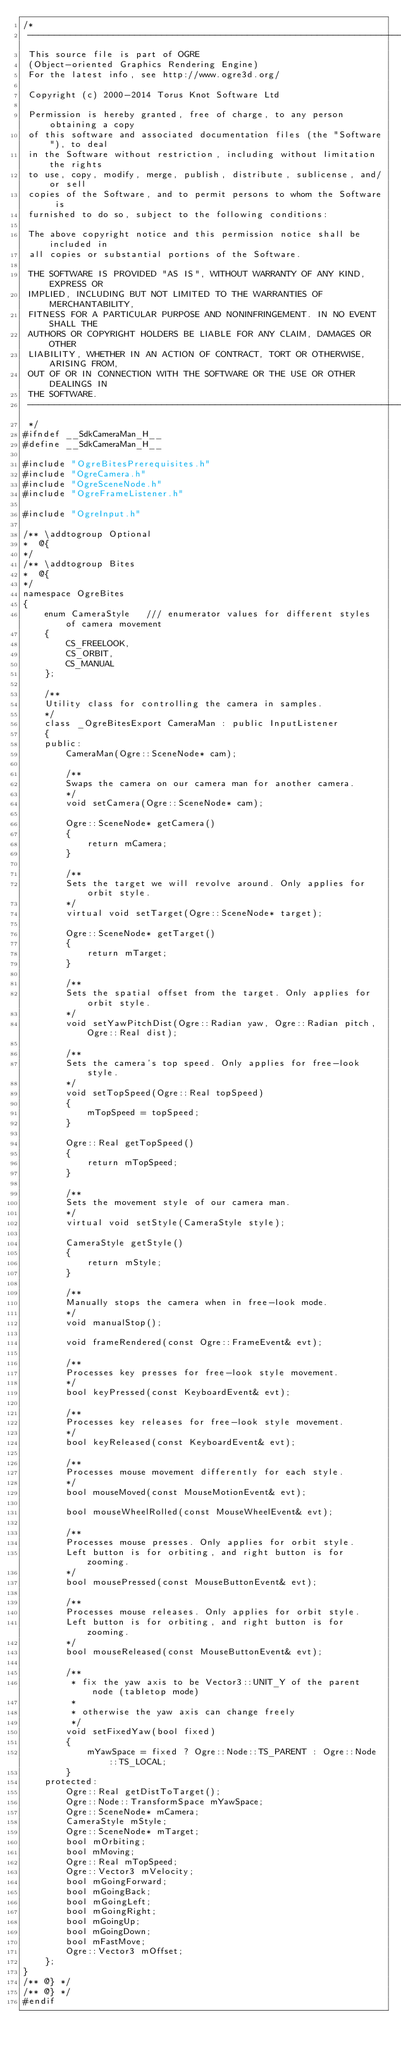Convert code to text. <code><loc_0><loc_0><loc_500><loc_500><_C_>/*
 -----------------------------------------------------------------------------
 This source file is part of OGRE
 (Object-oriented Graphics Rendering Engine)
 For the latest info, see http://www.ogre3d.org/

 Copyright (c) 2000-2014 Torus Knot Software Ltd

 Permission is hereby granted, free of charge, to any person obtaining a copy
 of this software and associated documentation files (the "Software"), to deal
 in the Software without restriction, including without limitation the rights
 to use, copy, modify, merge, publish, distribute, sublicense, and/or sell
 copies of the Software, and to permit persons to whom the Software is
 furnished to do so, subject to the following conditions:

 The above copyright notice and this permission notice shall be included in
 all copies or substantial portions of the Software.

 THE SOFTWARE IS PROVIDED "AS IS", WITHOUT WARRANTY OF ANY KIND, EXPRESS OR
 IMPLIED, INCLUDING BUT NOT LIMITED TO THE WARRANTIES OF MERCHANTABILITY,
 FITNESS FOR A PARTICULAR PURPOSE AND NONINFRINGEMENT. IN NO EVENT SHALL THE
 AUTHORS OR COPYRIGHT HOLDERS BE LIABLE FOR ANY CLAIM, DAMAGES OR OTHER
 LIABILITY, WHETHER IN AN ACTION OF CONTRACT, TORT OR OTHERWISE, ARISING FROM,
 OUT OF OR IN CONNECTION WITH THE SOFTWARE OR THE USE OR OTHER DEALINGS IN
 THE SOFTWARE.
 -----------------------------------------------------------------------------
 */
#ifndef __SdkCameraMan_H__
#define __SdkCameraMan_H__

#include "OgreBitesPrerequisites.h"
#include "OgreCamera.h"
#include "OgreSceneNode.h"
#include "OgreFrameListener.h"

#include "OgreInput.h"

/** \addtogroup Optional
*  @{
*/
/** \addtogroup Bites
*  @{
*/
namespace OgreBites
{
    enum CameraStyle   /// enumerator values for different styles of camera movement
    {
        CS_FREELOOK,
        CS_ORBIT,
        CS_MANUAL
    };

    /**
    Utility class for controlling the camera in samples.
    */
    class _OgreBitesExport CameraMan : public InputListener
    {
    public:
        CameraMan(Ogre::SceneNode* cam);

        /**
        Swaps the camera on our camera man for another camera.
        */
        void setCamera(Ogre::SceneNode* cam);

        Ogre::SceneNode* getCamera()
        {
            return mCamera;
        }

        /**
        Sets the target we will revolve around. Only applies for orbit style.
        */
        virtual void setTarget(Ogre::SceneNode* target);

        Ogre::SceneNode* getTarget()
        {
            return mTarget;
        }

        /**
        Sets the spatial offset from the target. Only applies for orbit style.
        */
        void setYawPitchDist(Ogre::Radian yaw, Ogre::Radian pitch, Ogre::Real dist);

        /**
        Sets the camera's top speed. Only applies for free-look style.
        */
        void setTopSpeed(Ogre::Real topSpeed)
        {
            mTopSpeed = topSpeed;
        }

        Ogre::Real getTopSpeed()
        {
            return mTopSpeed;
        }

        /**
        Sets the movement style of our camera man.
        */
        virtual void setStyle(CameraStyle style);

        CameraStyle getStyle()
        {
            return mStyle;
        }

        /**
        Manually stops the camera when in free-look mode.
        */
        void manualStop();

        void frameRendered(const Ogre::FrameEvent& evt);

        /**
        Processes key presses for free-look style movement.
        */
        bool keyPressed(const KeyboardEvent& evt);

        /**
        Processes key releases for free-look style movement.
        */
        bool keyReleased(const KeyboardEvent& evt);

        /**
        Processes mouse movement differently for each style.
        */
        bool mouseMoved(const MouseMotionEvent& evt);

        bool mouseWheelRolled(const MouseWheelEvent& evt);

        /**
        Processes mouse presses. Only applies for orbit style.
        Left button is for orbiting, and right button is for zooming.
        */
        bool mousePressed(const MouseButtonEvent& evt);

        /**
        Processes mouse releases. Only applies for orbit style.
        Left button is for orbiting, and right button is for zooming.
        */
        bool mouseReleased(const MouseButtonEvent& evt);

        /**
         * fix the yaw axis to be Vector3::UNIT_Y of the parent node (tabletop mode)
         * 
         * otherwise the yaw axis can change freely
         */
        void setFixedYaw(bool fixed)
        {
            mYawSpace = fixed ? Ogre::Node::TS_PARENT : Ogre::Node::TS_LOCAL;
        }
    protected:
        Ogre::Real getDistToTarget();
        Ogre::Node::TransformSpace mYawSpace;
        Ogre::SceneNode* mCamera;
        CameraStyle mStyle;
        Ogre::SceneNode* mTarget;
        bool mOrbiting;
        bool mMoving;
        Ogre::Real mTopSpeed;
        Ogre::Vector3 mVelocity;
        bool mGoingForward;
        bool mGoingBack;
        bool mGoingLeft;
        bool mGoingRight;
        bool mGoingUp;
        bool mGoingDown;
        bool mFastMove;
        Ogre::Vector3 mOffset;
    };
}
/** @} */
/** @} */
#endif
</code> 